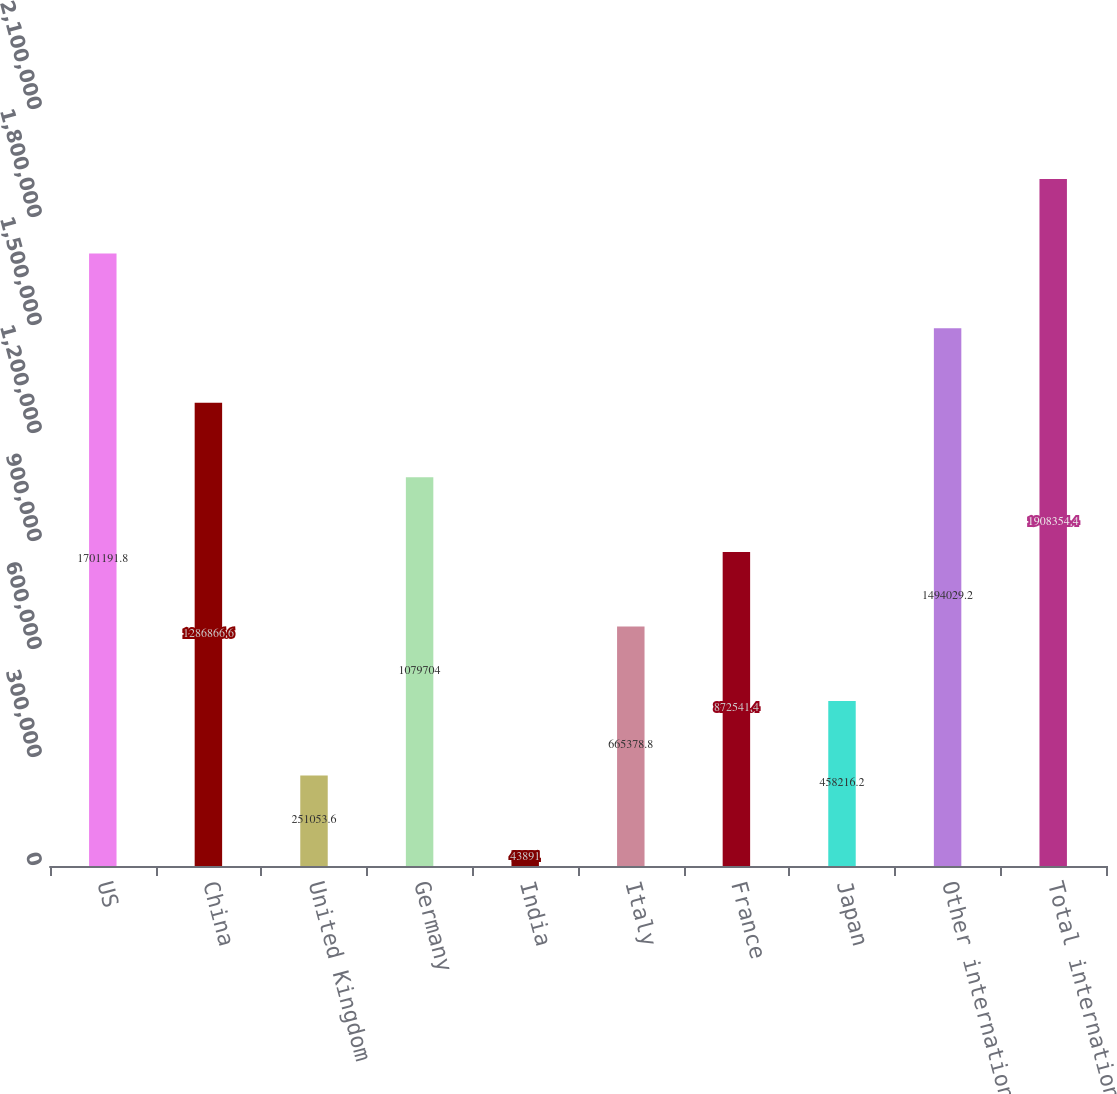<chart> <loc_0><loc_0><loc_500><loc_500><bar_chart><fcel>US<fcel>China<fcel>United Kingdom<fcel>Germany<fcel>India<fcel>Italy<fcel>France<fcel>Japan<fcel>Other international<fcel>Total international<nl><fcel>1.70119e+06<fcel>1.28687e+06<fcel>251054<fcel>1.0797e+06<fcel>43891<fcel>665379<fcel>872541<fcel>458216<fcel>1.49403e+06<fcel>1.90835e+06<nl></chart> 